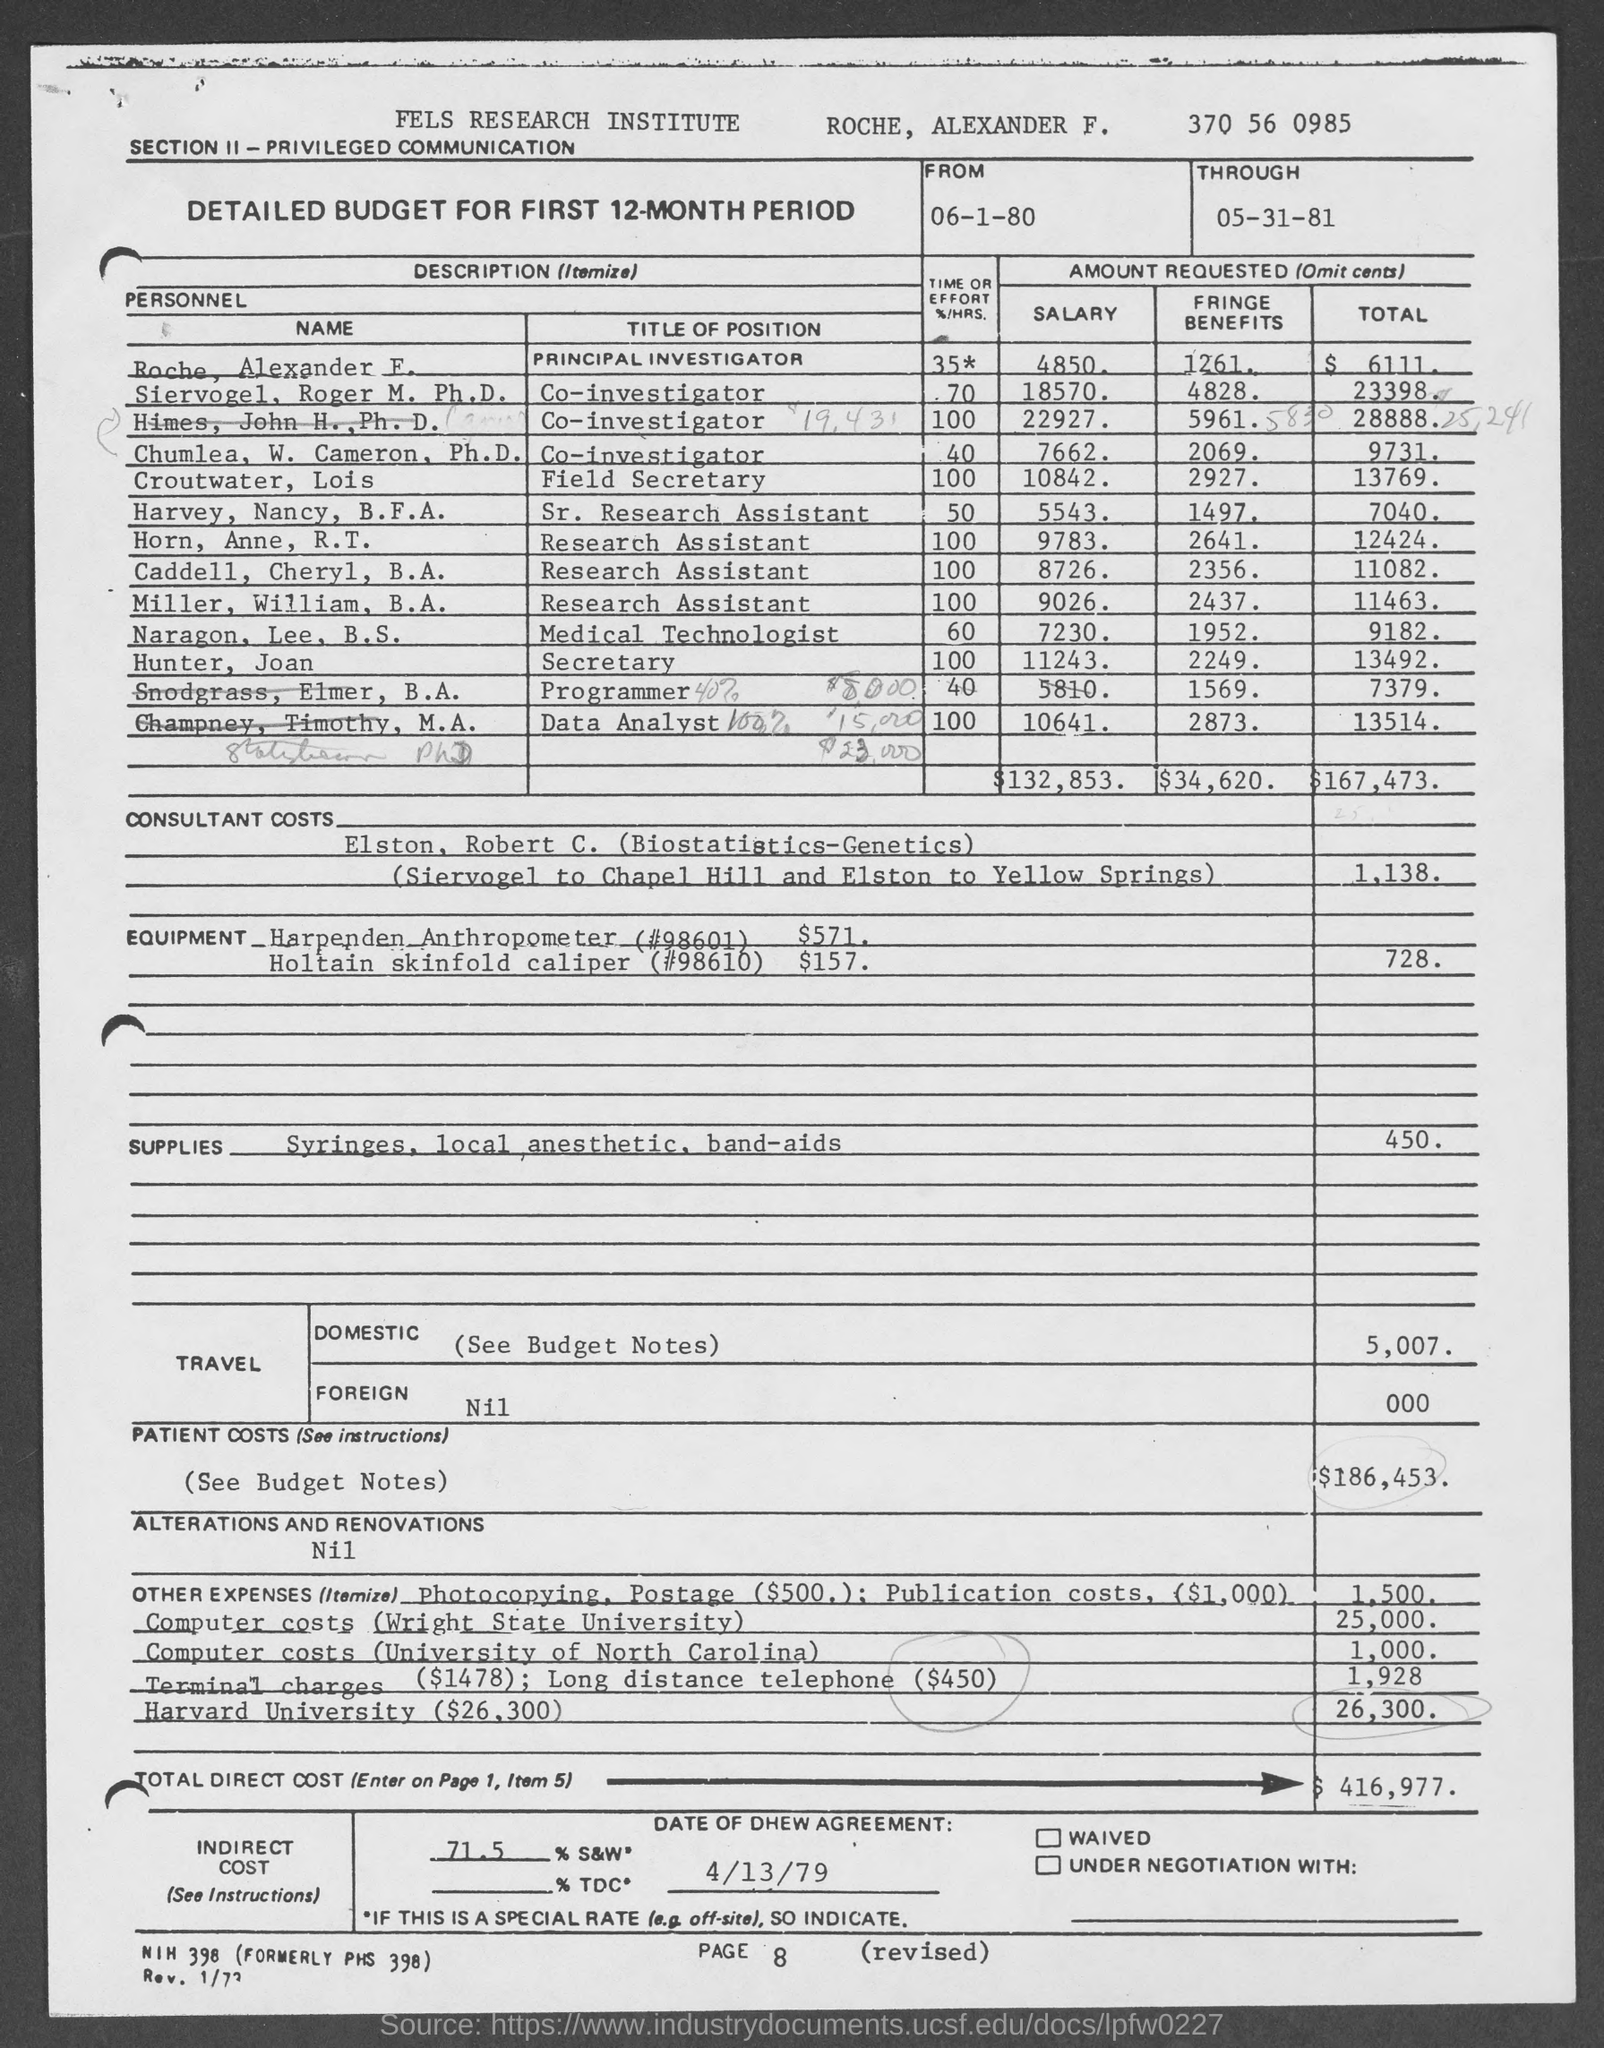What is the Institute Name ?
Offer a terse response. FELS RESEARCH INSTITUTE. What is the position of Naragon, Lee, B. S. ?
Your answer should be compact. Medical Technologist. What is the Through Date ?
Your response must be concise. 05-31-81. How much salary of Croutwater, Lois ?
Provide a short and direct response. 10842. How much total amount requested by Hunter, Joan ?
Offer a very short reply. 13492. Who is the Field Secretary ?
Give a very brief answer. Croutwater, Lois. 